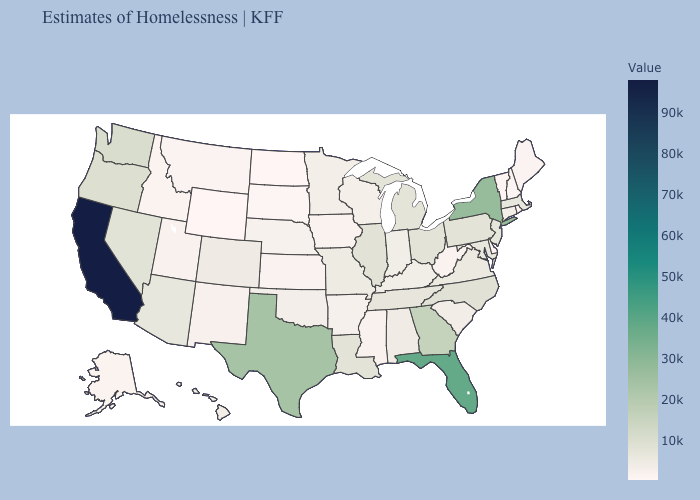Among the states that border Maine , which have the lowest value?
Write a very short answer. New Hampshire. Which states have the highest value in the USA?
Short answer required. California. Does Indiana have the lowest value in the USA?
Be succinct. No. 